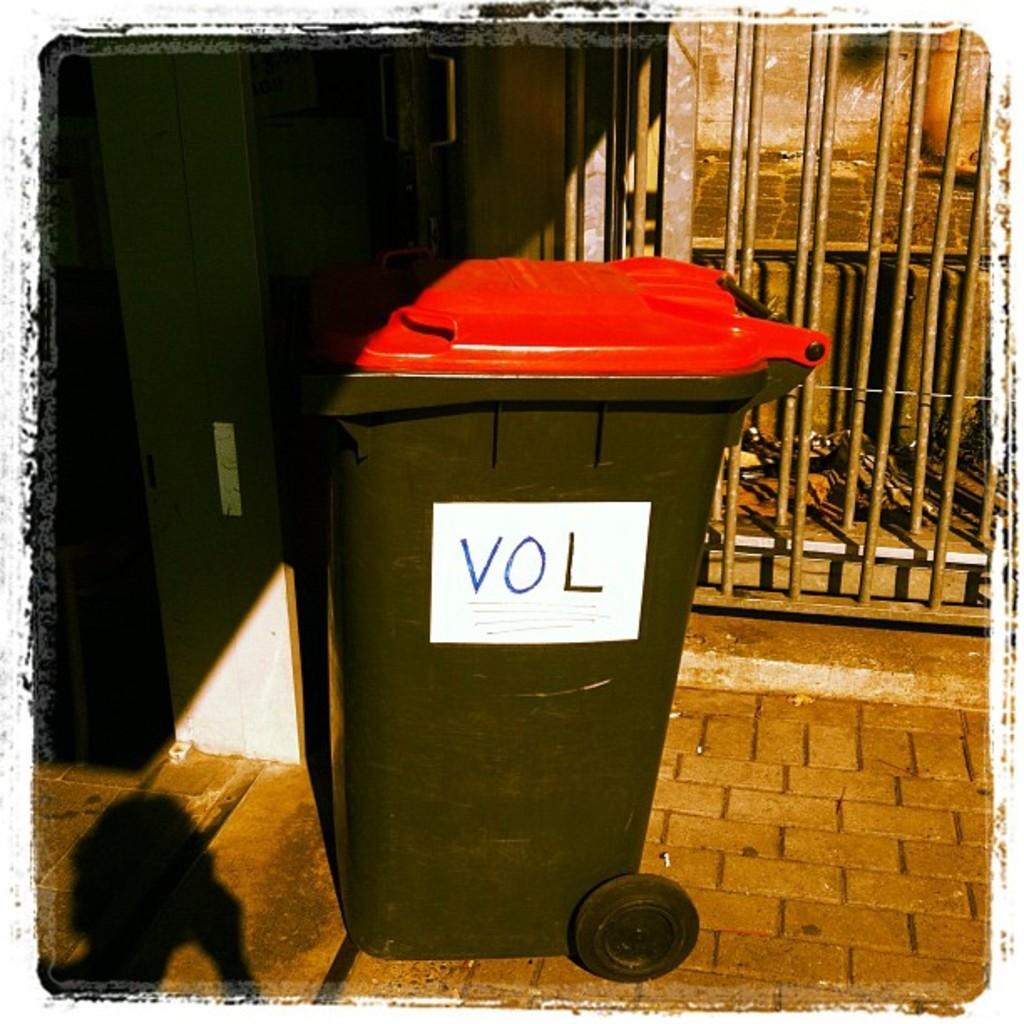What is written on the side of the trash bin?
Your answer should be very brief. Vol. What is written on this trash can?
Your response must be concise. Vol. 